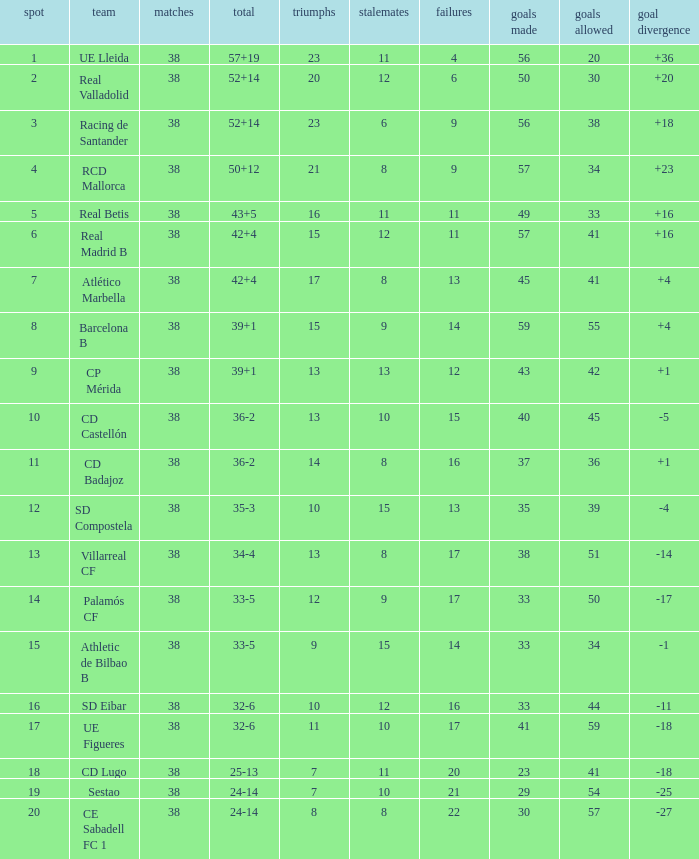What is the highest number of loss with a 7 position and more than 45 goals? None. 